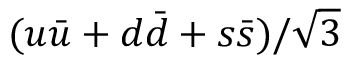Convert formula to latex. <formula><loc_0><loc_0><loc_500><loc_500>( u \bar { u } + d \bar { d } + s \bar { s } ) / \sqrt { 3 }</formula> 